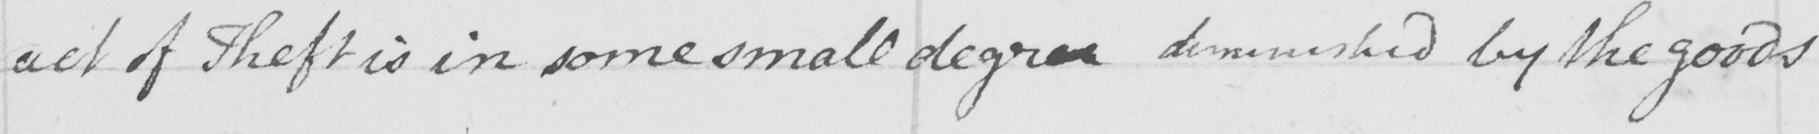Please transcribe the handwritten text in this image. act of Theft is in some small degree deminished by the goods 